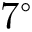<formula> <loc_0><loc_0><loc_500><loc_500>7 ^ { \circ }</formula> 